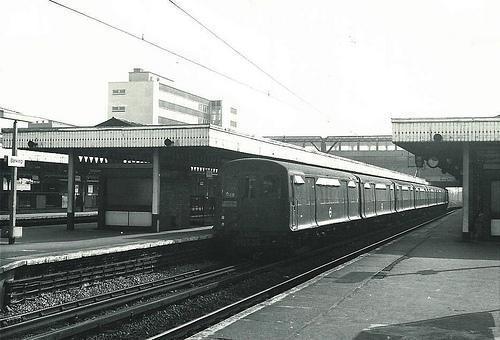How many trains are in the picture?
Give a very brief answer. 1. How many buildings are in the background?
Give a very brief answer. 1. How many power lines are above the train?
Give a very brief answer. 2. How many covered platforms are there?
Give a very brief answer. 3. 